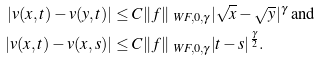Convert formula to latex. <formula><loc_0><loc_0><loc_500><loc_500>| v ( x , t ) - v ( y , t ) | & \leq C \| f \| _ { \ W F , 0 , \gamma } | \sqrt { x } - \sqrt { y } | ^ { \gamma } \text {    and } \\ | v ( x , t ) - v ( x , s ) | & \leq C \| f \| _ { \ W F , 0 , \gamma } | t - s | ^ { \frac { \gamma } { 2 } } .</formula> 